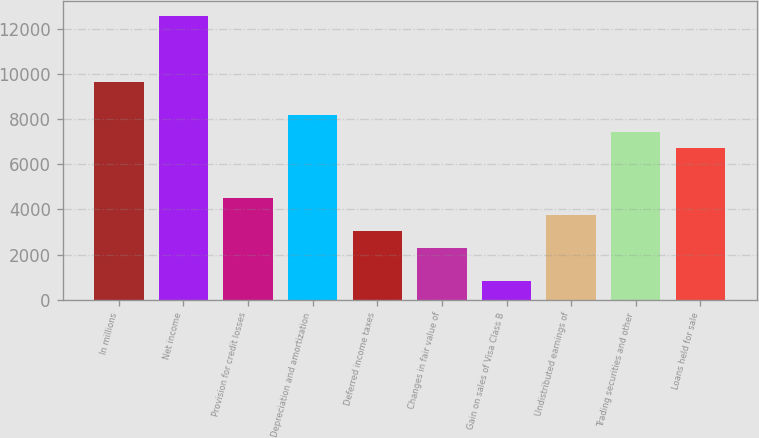Convert chart to OTSL. <chart><loc_0><loc_0><loc_500><loc_500><bar_chart><fcel>In millions<fcel>Net income<fcel>Provision for credit losses<fcel>Depreciation and amortization<fcel>Deferred income taxes<fcel>Changes in fair value of<fcel>Gain on sales of Visa Class B<fcel>Undistributed earnings of<fcel>Trading securities and other<fcel>Loans held for sale<nl><fcel>9644.6<fcel>12581.4<fcel>4505.2<fcel>8176.2<fcel>3036.8<fcel>2302.6<fcel>834.2<fcel>3771<fcel>7442<fcel>6707.8<nl></chart> 